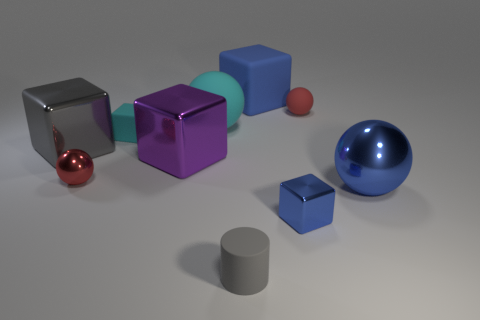Subtract all blue cylinders. How many blue blocks are left? 2 Subtract all gray cubes. How many cubes are left? 4 Subtract 3 blocks. How many blocks are left? 2 Subtract all blue cubes. How many cubes are left? 3 Subtract all purple spheres. Subtract all red cylinders. How many spheres are left? 4 Subtract all spheres. How many objects are left? 6 Add 9 blue metallic cylinders. How many blue metallic cylinders exist? 9 Subtract 0 green spheres. How many objects are left? 10 Subtract all brown metallic things. Subtract all tiny red matte balls. How many objects are left? 9 Add 5 large gray metallic things. How many large gray metallic things are left? 6 